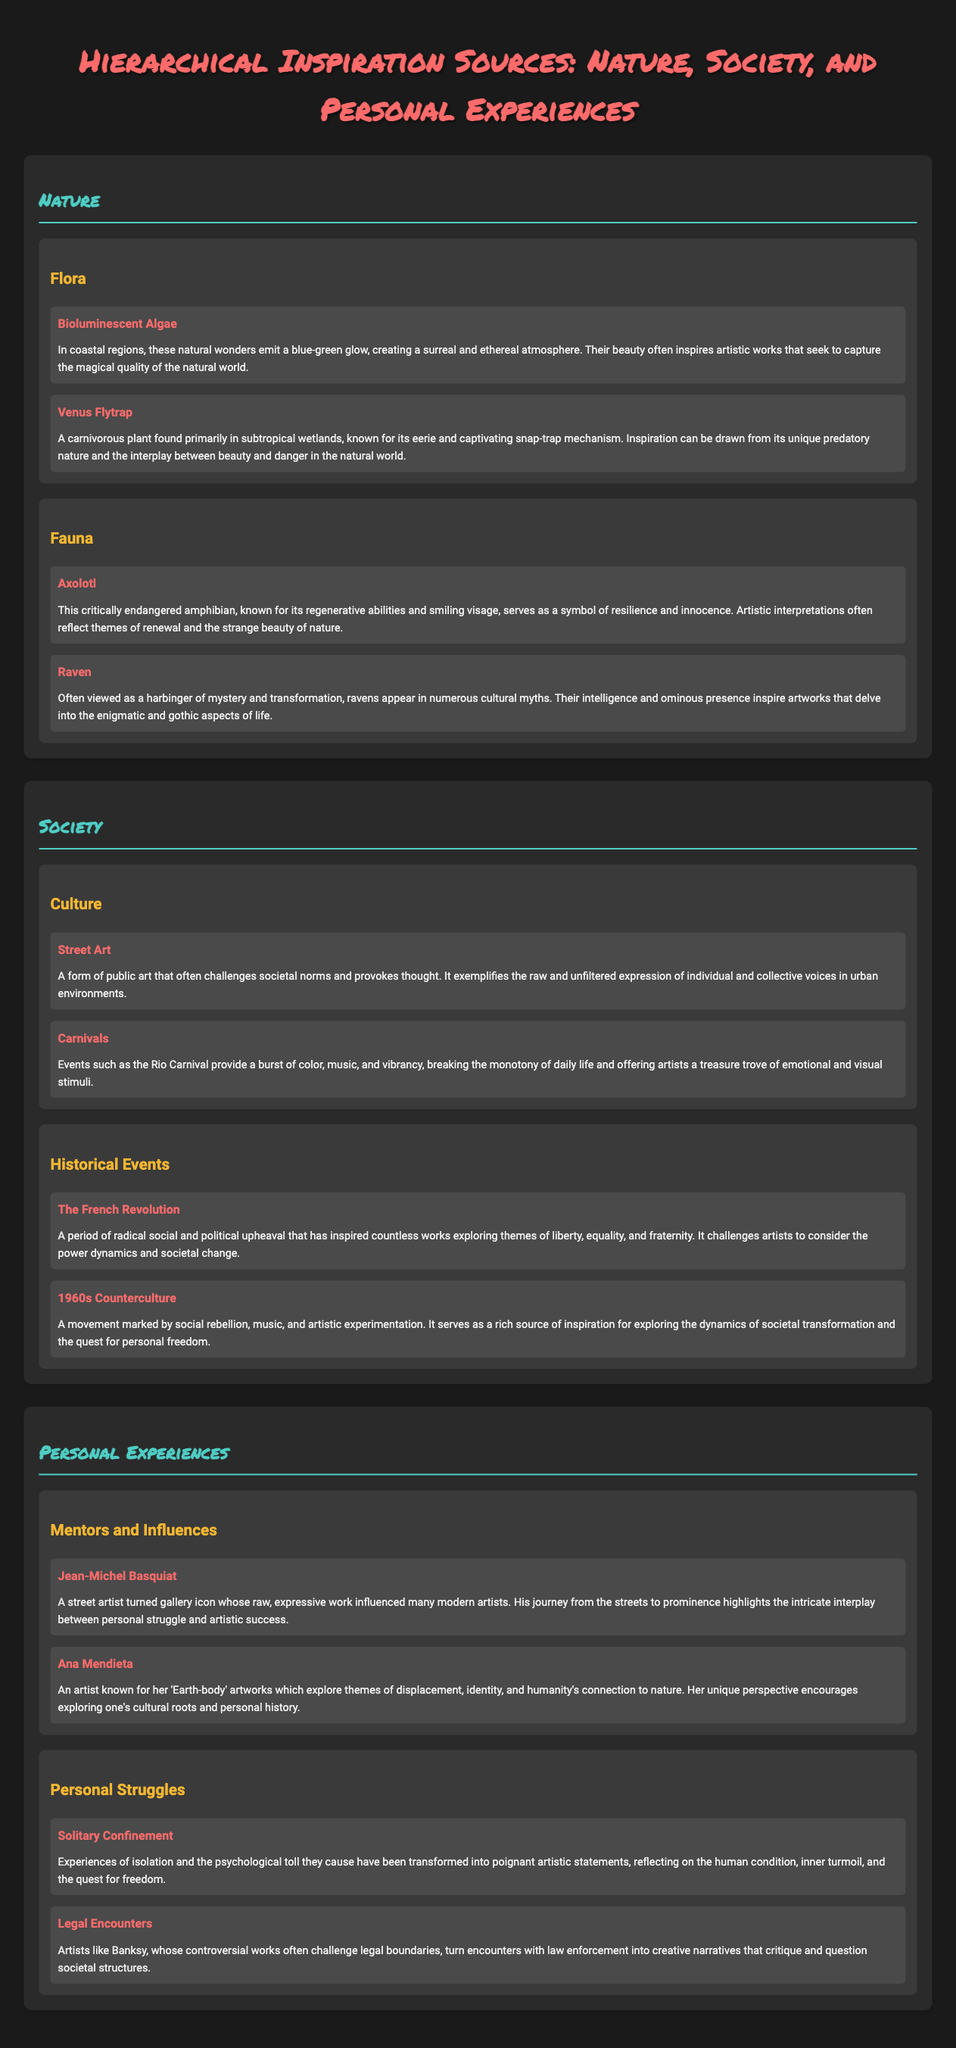What are the two main categories of inspiration sources? The document outlines three main categories: Nature, Society, and Personal Experiences.
Answer: Nature, Society, Personal Experiences Which animal represents resilience and innocence? The document mentions the Axolotl as a symbol of resilience and innocence.
Answer: Axolotl What type of art is discussed under the society category that challenges societal norms? The document refers to Street Art as a form of public art that challenges societal norms.
Answer: Street Art What historical period inspired themes of liberty and equality? The document identifies The French Revolution as a period inspiring themes of liberty, equality, and fraternity.
Answer: The French Revolution Which artist is known for their 'Earth-body' artworks? The document states Ana Mendieta is known for her 'Earth-body' artworks.
Answer: Ana Mendieta What is the relationship between legal encounters and artistic expression mentioned in the document? The document highlights that artists like Banksy turn legal encounters into creative narratives questioning societal structures.
Answer: Creative narratives In which category would you find the Venus Flytrap? The Venus Flytrap is categorized under Flora in the Nature section.
Answer: Flora What inspired artists during the 1960s Counterculture? The document mentions social rebellion, music, and artistic experimentation as inspirations from the 1960s Counterculture.
Answer: Social rebellion, music, artistic experimentation What unique feature does the Raven represent in artistic works? The document notes that the Raven represents mystery and transformation in artistic interpretations.
Answer: Mystery and transformation 